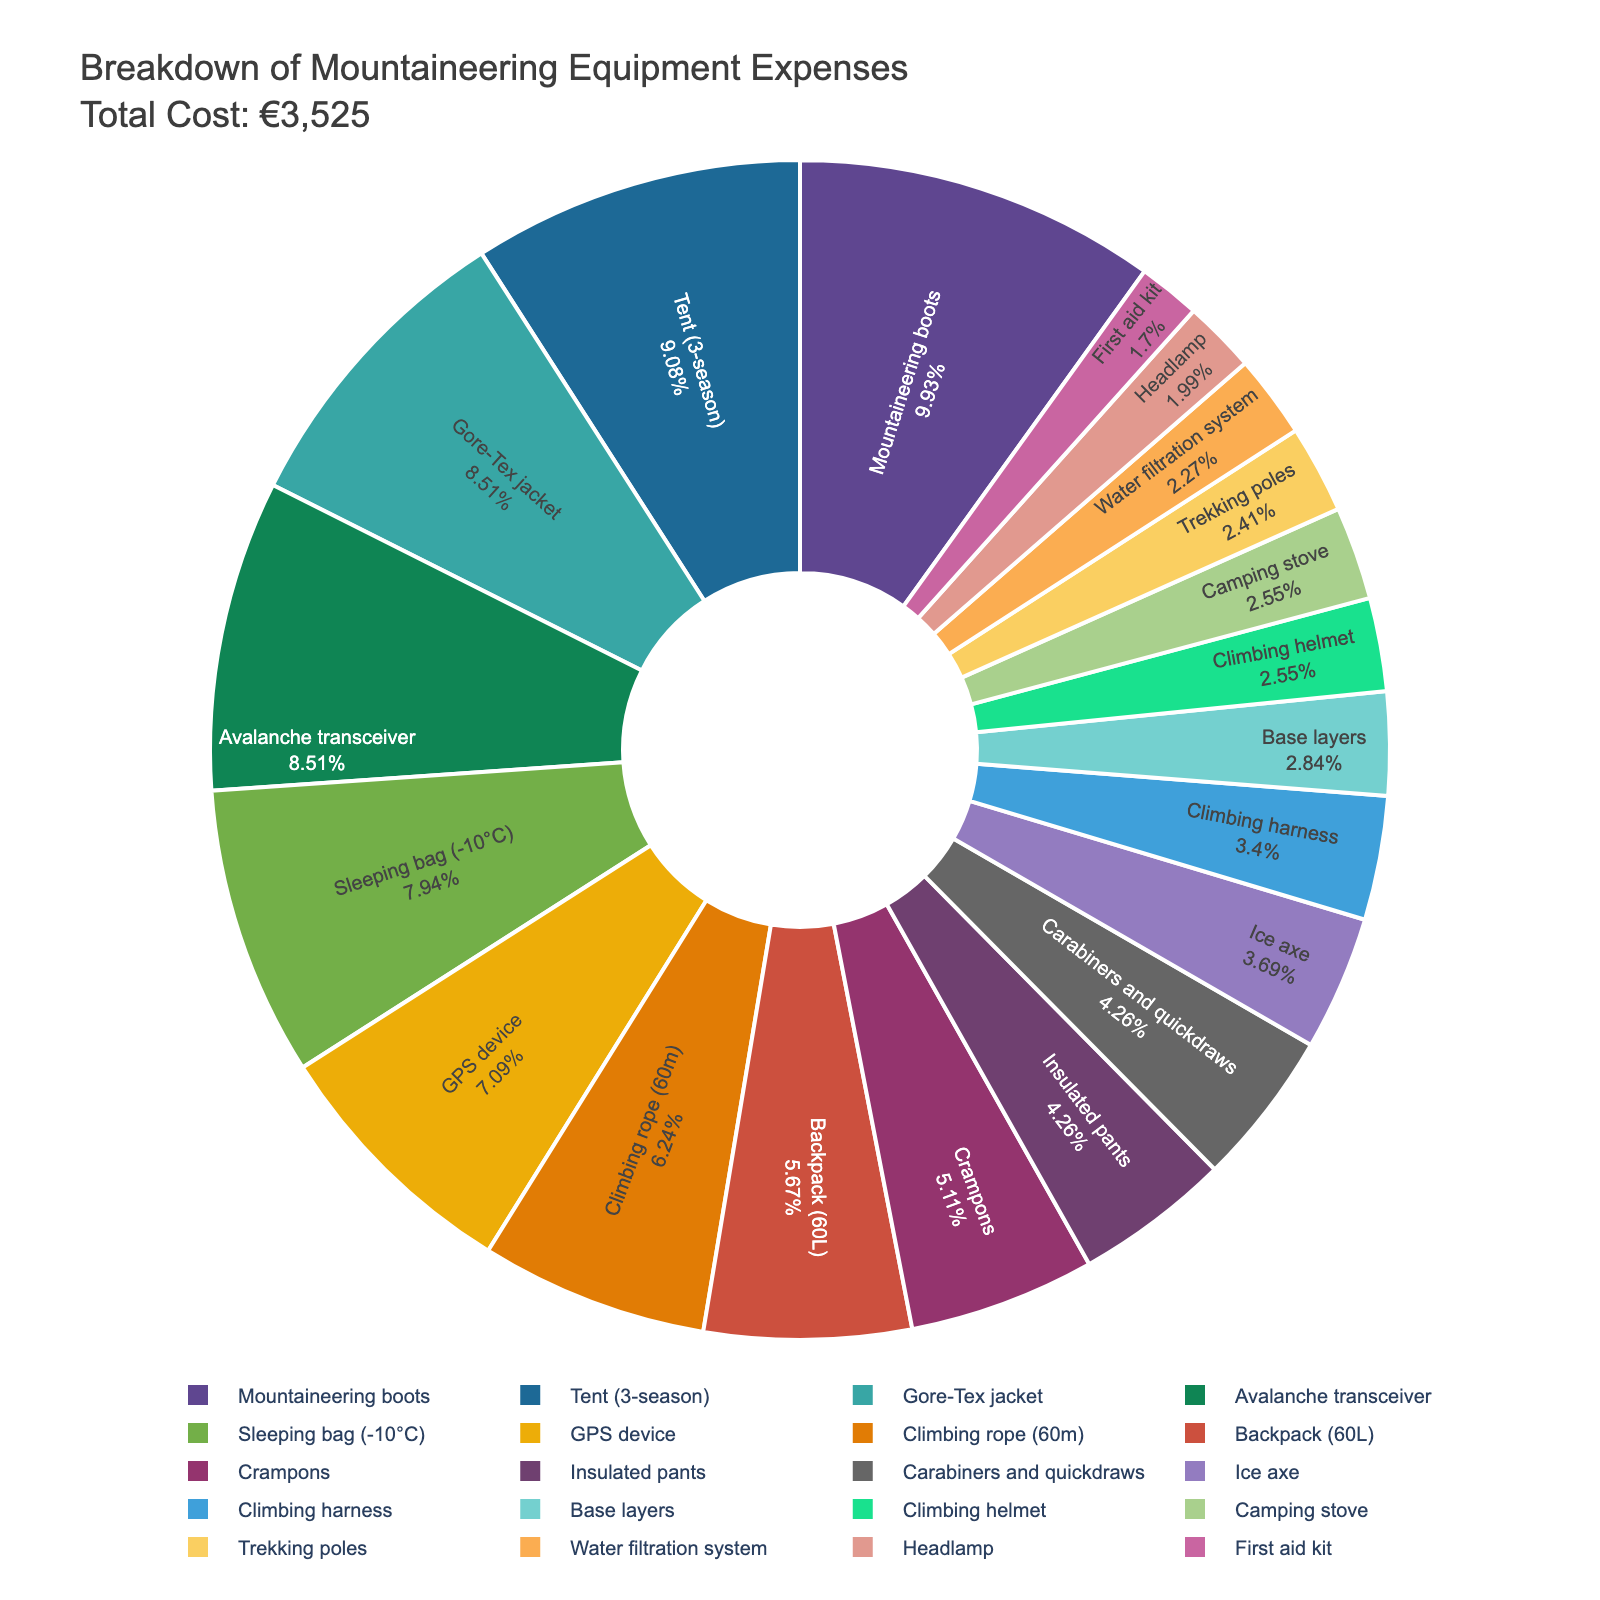What is the equipment with the highest expense? Examine the pie chart to identify the segment that occupies the largest portion, which corresponds to the highest cost.
Answer: Mountaineering boots Which equipment has a lower expense, the climbing helmet or the base layers? Locate the segments for both climbing helmet and base layers in the pie chart and compare their sizes. The climbing helmet's segment is smaller.
Answer: Climbing helmet What is the combined cost of the sleeping bag and the tent? Find the segments for both the sleeping bag and tent. Sum their costs: €280 (sleeping bag) + €320 (tent) = €600.
Answer: €600 How many equipment items have an expense of €150 or more? Count the segments representing equipment items with costs of €150 or more: Mountaineering boots, Sleeping bag, Tent, Gore-Tex jacket, Insulated pants, Climbing rope, Avalanche transceiver. There are 7 items.
Answer: 7 Is the cost of the Gore-Tex jacket higher than the cost of the tent? Locate and compare the segments for the Gore-Tex jacket and tent. The tent's segment is larger, indicating a higher cost.
Answer: No Which item has approximately twice the expense of the water filtration system? The water filtration system costs €80. Identify the item with double that cost, roughly €160. Crampons, with a cost of €180, best match this criterion.
Answer: Crampons What proportion of the total cost is contributed by the GPS device? Identify the GPS device segment and check its labeled percentage representation within the pie chart.
Answer: 6.33% What's the difference in the cost between the ice axe and the trekking poles? Locate the segments for the ice axe (€130) and trekking poles (€85). Calculate the difference: €130 - €85 = €45.
Answer: €45 Are there more items costing over €200 or under €200? Count items costing over €200 (Mountaineering boots, Backpack, Sleeping bag, Tent, Gore-Tex jacket, Climbing rope, Avalanche transceiver which totals 7) and under €200 (the remaining 13 items).
Answer: Under €200 Which segment represents the smallest expense, and what is it? Identify the smallest segment in the pie chart, which corresponds to the smallest cost item. This is the First aid kit.
Answer: First aid kit 